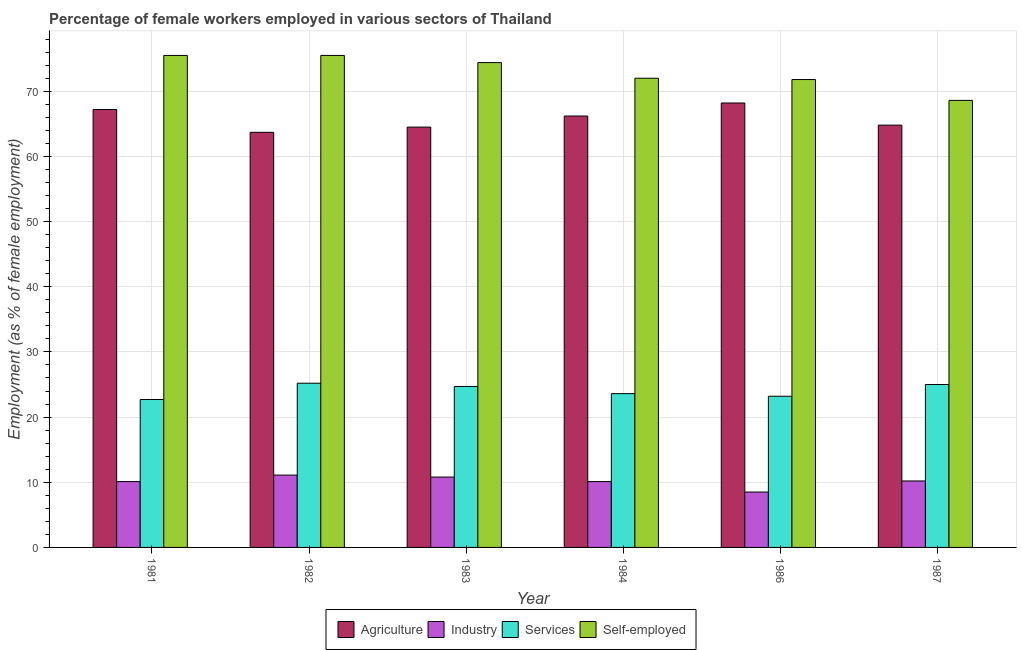How many different coloured bars are there?
Make the answer very short. 4. Are the number of bars on each tick of the X-axis equal?
Make the answer very short. Yes. How many bars are there on the 3rd tick from the right?
Offer a very short reply. 4. What is the percentage of female workers in industry in 1982?
Provide a succinct answer. 11.1. Across all years, what is the maximum percentage of female workers in industry?
Provide a succinct answer. 11.1. Across all years, what is the minimum percentage of female workers in agriculture?
Provide a succinct answer. 63.7. In which year was the percentage of self employed female workers maximum?
Give a very brief answer. 1981. In which year was the percentage of self employed female workers minimum?
Keep it short and to the point. 1987. What is the total percentage of female workers in industry in the graph?
Offer a very short reply. 60.8. What is the difference between the percentage of self employed female workers in 1982 and the percentage of female workers in industry in 1984?
Make the answer very short. 3.5. What is the average percentage of female workers in industry per year?
Offer a terse response. 10.13. What is the ratio of the percentage of self employed female workers in 1986 to that in 1987?
Offer a terse response. 1.05. Is the percentage of self employed female workers in 1983 less than that in 1984?
Provide a succinct answer. No. Is the difference between the percentage of female workers in industry in 1983 and 1986 greater than the difference between the percentage of female workers in services in 1983 and 1986?
Keep it short and to the point. No. What is the difference between the highest and the lowest percentage of female workers in services?
Keep it short and to the point. 2.5. In how many years, is the percentage of self employed female workers greater than the average percentage of self employed female workers taken over all years?
Provide a short and direct response. 3. Is the sum of the percentage of female workers in industry in 1981 and 1982 greater than the maximum percentage of self employed female workers across all years?
Make the answer very short. Yes. Is it the case that in every year, the sum of the percentage of female workers in agriculture and percentage of female workers in services is greater than the sum of percentage of self employed female workers and percentage of female workers in industry?
Your answer should be very brief. Yes. What does the 4th bar from the left in 1986 represents?
Offer a very short reply. Self-employed. What does the 1st bar from the right in 1984 represents?
Your answer should be compact. Self-employed. Is it the case that in every year, the sum of the percentage of female workers in agriculture and percentage of female workers in industry is greater than the percentage of female workers in services?
Provide a succinct answer. Yes. Are all the bars in the graph horizontal?
Your answer should be compact. No. How many years are there in the graph?
Your answer should be very brief. 6. How are the legend labels stacked?
Your answer should be compact. Horizontal. What is the title of the graph?
Provide a short and direct response. Percentage of female workers employed in various sectors of Thailand. What is the label or title of the X-axis?
Your response must be concise. Year. What is the label or title of the Y-axis?
Offer a terse response. Employment (as % of female employment). What is the Employment (as % of female employment) in Agriculture in 1981?
Make the answer very short. 67.2. What is the Employment (as % of female employment) in Industry in 1981?
Keep it short and to the point. 10.1. What is the Employment (as % of female employment) of Services in 1981?
Keep it short and to the point. 22.7. What is the Employment (as % of female employment) of Self-employed in 1981?
Your response must be concise. 75.5. What is the Employment (as % of female employment) of Agriculture in 1982?
Give a very brief answer. 63.7. What is the Employment (as % of female employment) of Industry in 1982?
Ensure brevity in your answer.  11.1. What is the Employment (as % of female employment) of Services in 1982?
Offer a terse response. 25.2. What is the Employment (as % of female employment) of Self-employed in 1982?
Your answer should be very brief. 75.5. What is the Employment (as % of female employment) in Agriculture in 1983?
Give a very brief answer. 64.5. What is the Employment (as % of female employment) of Industry in 1983?
Provide a short and direct response. 10.8. What is the Employment (as % of female employment) of Services in 1983?
Provide a short and direct response. 24.7. What is the Employment (as % of female employment) in Self-employed in 1983?
Your response must be concise. 74.4. What is the Employment (as % of female employment) of Agriculture in 1984?
Provide a succinct answer. 66.2. What is the Employment (as % of female employment) in Industry in 1984?
Your answer should be compact. 10.1. What is the Employment (as % of female employment) of Services in 1984?
Your answer should be compact. 23.6. What is the Employment (as % of female employment) of Self-employed in 1984?
Offer a terse response. 72. What is the Employment (as % of female employment) in Agriculture in 1986?
Provide a succinct answer. 68.2. What is the Employment (as % of female employment) of Services in 1986?
Your answer should be very brief. 23.2. What is the Employment (as % of female employment) in Self-employed in 1986?
Provide a short and direct response. 71.8. What is the Employment (as % of female employment) in Agriculture in 1987?
Ensure brevity in your answer.  64.8. What is the Employment (as % of female employment) of Industry in 1987?
Ensure brevity in your answer.  10.2. What is the Employment (as % of female employment) in Services in 1987?
Your answer should be compact. 25. What is the Employment (as % of female employment) of Self-employed in 1987?
Your response must be concise. 68.6. Across all years, what is the maximum Employment (as % of female employment) of Agriculture?
Keep it short and to the point. 68.2. Across all years, what is the maximum Employment (as % of female employment) of Industry?
Provide a succinct answer. 11.1. Across all years, what is the maximum Employment (as % of female employment) of Services?
Give a very brief answer. 25.2. Across all years, what is the maximum Employment (as % of female employment) of Self-employed?
Offer a terse response. 75.5. Across all years, what is the minimum Employment (as % of female employment) of Agriculture?
Provide a short and direct response. 63.7. Across all years, what is the minimum Employment (as % of female employment) in Industry?
Provide a succinct answer. 8.5. Across all years, what is the minimum Employment (as % of female employment) of Services?
Ensure brevity in your answer.  22.7. Across all years, what is the minimum Employment (as % of female employment) of Self-employed?
Provide a succinct answer. 68.6. What is the total Employment (as % of female employment) of Agriculture in the graph?
Make the answer very short. 394.6. What is the total Employment (as % of female employment) in Industry in the graph?
Keep it short and to the point. 60.8. What is the total Employment (as % of female employment) in Services in the graph?
Your response must be concise. 144.4. What is the total Employment (as % of female employment) in Self-employed in the graph?
Offer a terse response. 437.8. What is the difference between the Employment (as % of female employment) in Agriculture in 1981 and that in 1982?
Your answer should be compact. 3.5. What is the difference between the Employment (as % of female employment) in Industry in 1981 and that in 1982?
Offer a terse response. -1. What is the difference between the Employment (as % of female employment) of Agriculture in 1981 and that in 1983?
Make the answer very short. 2.7. What is the difference between the Employment (as % of female employment) in Services in 1981 and that in 1984?
Provide a succinct answer. -0.9. What is the difference between the Employment (as % of female employment) in Self-employed in 1981 and that in 1984?
Your answer should be compact. 3.5. What is the difference between the Employment (as % of female employment) in Agriculture in 1981 and that in 1986?
Offer a terse response. -1. What is the difference between the Employment (as % of female employment) of Industry in 1981 and that in 1986?
Offer a terse response. 1.6. What is the difference between the Employment (as % of female employment) of Agriculture in 1981 and that in 1987?
Your answer should be very brief. 2.4. What is the difference between the Employment (as % of female employment) of Services in 1981 and that in 1987?
Give a very brief answer. -2.3. What is the difference between the Employment (as % of female employment) of Industry in 1982 and that in 1983?
Give a very brief answer. 0.3. What is the difference between the Employment (as % of female employment) of Industry in 1982 and that in 1984?
Ensure brevity in your answer.  1. What is the difference between the Employment (as % of female employment) in Services in 1982 and that in 1984?
Provide a succinct answer. 1.6. What is the difference between the Employment (as % of female employment) of Self-employed in 1982 and that in 1984?
Provide a short and direct response. 3.5. What is the difference between the Employment (as % of female employment) in Agriculture in 1982 and that in 1986?
Ensure brevity in your answer.  -4.5. What is the difference between the Employment (as % of female employment) of Industry in 1982 and that in 1986?
Your response must be concise. 2.6. What is the difference between the Employment (as % of female employment) of Services in 1982 and that in 1986?
Your answer should be very brief. 2. What is the difference between the Employment (as % of female employment) of Self-employed in 1982 and that in 1986?
Ensure brevity in your answer.  3.7. What is the difference between the Employment (as % of female employment) in Self-employed in 1982 and that in 1987?
Keep it short and to the point. 6.9. What is the difference between the Employment (as % of female employment) of Agriculture in 1983 and that in 1984?
Your answer should be very brief. -1.7. What is the difference between the Employment (as % of female employment) in Services in 1983 and that in 1984?
Keep it short and to the point. 1.1. What is the difference between the Employment (as % of female employment) of Self-employed in 1983 and that in 1984?
Ensure brevity in your answer.  2.4. What is the difference between the Employment (as % of female employment) in Agriculture in 1983 and that in 1986?
Your answer should be very brief. -3.7. What is the difference between the Employment (as % of female employment) in Services in 1983 and that in 1986?
Provide a short and direct response. 1.5. What is the difference between the Employment (as % of female employment) of Industry in 1983 and that in 1987?
Your answer should be very brief. 0.6. What is the difference between the Employment (as % of female employment) of Self-employed in 1983 and that in 1987?
Keep it short and to the point. 5.8. What is the difference between the Employment (as % of female employment) in Industry in 1984 and that in 1986?
Keep it short and to the point. 1.6. What is the difference between the Employment (as % of female employment) of Agriculture in 1986 and that in 1987?
Ensure brevity in your answer.  3.4. What is the difference between the Employment (as % of female employment) of Industry in 1986 and that in 1987?
Ensure brevity in your answer.  -1.7. What is the difference between the Employment (as % of female employment) of Services in 1986 and that in 1987?
Offer a terse response. -1.8. What is the difference between the Employment (as % of female employment) of Agriculture in 1981 and the Employment (as % of female employment) of Industry in 1982?
Offer a very short reply. 56.1. What is the difference between the Employment (as % of female employment) in Industry in 1981 and the Employment (as % of female employment) in Services in 1982?
Your answer should be compact. -15.1. What is the difference between the Employment (as % of female employment) of Industry in 1981 and the Employment (as % of female employment) of Self-employed in 1982?
Offer a terse response. -65.4. What is the difference between the Employment (as % of female employment) of Services in 1981 and the Employment (as % of female employment) of Self-employed in 1982?
Provide a succinct answer. -52.8. What is the difference between the Employment (as % of female employment) in Agriculture in 1981 and the Employment (as % of female employment) in Industry in 1983?
Make the answer very short. 56.4. What is the difference between the Employment (as % of female employment) of Agriculture in 1981 and the Employment (as % of female employment) of Services in 1983?
Offer a terse response. 42.5. What is the difference between the Employment (as % of female employment) in Agriculture in 1981 and the Employment (as % of female employment) in Self-employed in 1983?
Your answer should be compact. -7.2. What is the difference between the Employment (as % of female employment) of Industry in 1981 and the Employment (as % of female employment) of Services in 1983?
Your answer should be very brief. -14.6. What is the difference between the Employment (as % of female employment) in Industry in 1981 and the Employment (as % of female employment) in Self-employed in 1983?
Keep it short and to the point. -64.3. What is the difference between the Employment (as % of female employment) in Services in 1981 and the Employment (as % of female employment) in Self-employed in 1983?
Give a very brief answer. -51.7. What is the difference between the Employment (as % of female employment) in Agriculture in 1981 and the Employment (as % of female employment) in Industry in 1984?
Your answer should be compact. 57.1. What is the difference between the Employment (as % of female employment) of Agriculture in 1981 and the Employment (as % of female employment) of Services in 1984?
Offer a terse response. 43.6. What is the difference between the Employment (as % of female employment) in Industry in 1981 and the Employment (as % of female employment) in Services in 1984?
Provide a short and direct response. -13.5. What is the difference between the Employment (as % of female employment) in Industry in 1981 and the Employment (as % of female employment) in Self-employed in 1984?
Keep it short and to the point. -61.9. What is the difference between the Employment (as % of female employment) in Services in 1981 and the Employment (as % of female employment) in Self-employed in 1984?
Give a very brief answer. -49.3. What is the difference between the Employment (as % of female employment) of Agriculture in 1981 and the Employment (as % of female employment) of Industry in 1986?
Make the answer very short. 58.7. What is the difference between the Employment (as % of female employment) in Agriculture in 1981 and the Employment (as % of female employment) in Services in 1986?
Provide a succinct answer. 44. What is the difference between the Employment (as % of female employment) of Agriculture in 1981 and the Employment (as % of female employment) of Self-employed in 1986?
Give a very brief answer. -4.6. What is the difference between the Employment (as % of female employment) of Industry in 1981 and the Employment (as % of female employment) of Self-employed in 1986?
Your answer should be compact. -61.7. What is the difference between the Employment (as % of female employment) in Services in 1981 and the Employment (as % of female employment) in Self-employed in 1986?
Provide a succinct answer. -49.1. What is the difference between the Employment (as % of female employment) in Agriculture in 1981 and the Employment (as % of female employment) in Services in 1987?
Your answer should be very brief. 42.2. What is the difference between the Employment (as % of female employment) in Agriculture in 1981 and the Employment (as % of female employment) in Self-employed in 1987?
Keep it short and to the point. -1.4. What is the difference between the Employment (as % of female employment) of Industry in 1981 and the Employment (as % of female employment) of Services in 1987?
Your answer should be very brief. -14.9. What is the difference between the Employment (as % of female employment) of Industry in 1981 and the Employment (as % of female employment) of Self-employed in 1987?
Offer a terse response. -58.5. What is the difference between the Employment (as % of female employment) of Services in 1981 and the Employment (as % of female employment) of Self-employed in 1987?
Your answer should be compact. -45.9. What is the difference between the Employment (as % of female employment) in Agriculture in 1982 and the Employment (as % of female employment) in Industry in 1983?
Your answer should be very brief. 52.9. What is the difference between the Employment (as % of female employment) of Agriculture in 1982 and the Employment (as % of female employment) of Self-employed in 1983?
Provide a succinct answer. -10.7. What is the difference between the Employment (as % of female employment) of Industry in 1982 and the Employment (as % of female employment) of Services in 1983?
Keep it short and to the point. -13.6. What is the difference between the Employment (as % of female employment) of Industry in 1982 and the Employment (as % of female employment) of Self-employed in 1983?
Offer a terse response. -63.3. What is the difference between the Employment (as % of female employment) in Services in 1982 and the Employment (as % of female employment) in Self-employed in 1983?
Give a very brief answer. -49.2. What is the difference between the Employment (as % of female employment) in Agriculture in 1982 and the Employment (as % of female employment) in Industry in 1984?
Your answer should be compact. 53.6. What is the difference between the Employment (as % of female employment) in Agriculture in 1982 and the Employment (as % of female employment) in Services in 1984?
Offer a terse response. 40.1. What is the difference between the Employment (as % of female employment) in Agriculture in 1982 and the Employment (as % of female employment) in Self-employed in 1984?
Your response must be concise. -8.3. What is the difference between the Employment (as % of female employment) of Industry in 1982 and the Employment (as % of female employment) of Self-employed in 1984?
Make the answer very short. -60.9. What is the difference between the Employment (as % of female employment) of Services in 1982 and the Employment (as % of female employment) of Self-employed in 1984?
Provide a succinct answer. -46.8. What is the difference between the Employment (as % of female employment) of Agriculture in 1982 and the Employment (as % of female employment) of Industry in 1986?
Your answer should be very brief. 55.2. What is the difference between the Employment (as % of female employment) in Agriculture in 1982 and the Employment (as % of female employment) in Services in 1986?
Make the answer very short. 40.5. What is the difference between the Employment (as % of female employment) of Agriculture in 1982 and the Employment (as % of female employment) of Self-employed in 1986?
Your answer should be compact. -8.1. What is the difference between the Employment (as % of female employment) in Industry in 1982 and the Employment (as % of female employment) in Self-employed in 1986?
Offer a terse response. -60.7. What is the difference between the Employment (as % of female employment) in Services in 1982 and the Employment (as % of female employment) in Self-employed in 1986?
Provide a short and direct response. -46.6. What is the difference between the Employment (as % of female employment) in Agriculture in 1982 and the Employment (as % of female employment) in Industry in 1987?
Offer a very short reply. 53.5. What is the difference between the Employment (as % of female employment) in Agriculture in 1982 and the Employment (as % of female employment) in Services in 1987?
Give a very brief answer. 38.7. What is the difference between the Employment (as % of female employment) in Industry in 1982 and the Employment (as % of female employment) in Services in 1987?
Your answer should be very brief. -13.9. What is the difference between the Employment (as % of female employment) of Industry in 1982 and the Employment (as % of female employment) of Self-employed in 1987?
Keep it short and to the point. -57.5. What is the difference between the Employment (as % of female employment) in Services in 1982 and the Employment (as % of female employment) in Self-employed in 1987?
Your answer should be very brief. -43.4. What is the difference between the Employment (as % of female employment) in Agriculture in 1983 and the Employment (as % of female employment) in Industry in 1984?
Keep it short and to the point. 54.4. What is the difference between the Employment (as % of female employment) in Agriculture in 1983 and the Employment (as % of female employment) in Services in 1984?
Your answer should be compact. 40.9. What is the difference between the Employment (as % of female employment) of Industry in 1983 and the Employment (as % of female employment) of Self-employed in 1984?
Keep it short and to the point. -61.2. What is the difference between the Employment (as % of female employment) in Services in 1983 and the Employment (as % of female employment) in Self-employed in 1984?
Make the answer very short. -47.3. What is the difference between the Employment (as % of female employment) in Agriculture in 1983 and the Employment (as % of female employment) in Services in 1986?
Offer a very short reply. 41.3. What is the difference between the Employment (as % of female employment) in Agriculture in 1983 and the Employment (as % of female employment) in Self-employed in 1986?
Keep it short and to the point. -7.3. What is the difference between the Employment (as % of female employment) in Industry in 1983 and the Employment (as % of female employment) in Self-employed in 1986?
Make the answer very short. -61. What is the difference between the Employment (as % of female employment) of Services in 1983 and the Employment (as % of female employment) of Self-employed in 1986?
Offer a terse response. -47.1. What is the difference between the Employment (as % of female employment) of Agriculture in 1983 and the Employment (as % of female employment) of Industry in 1987?
Keep it short and to the point. 54.3. What is the difference between the Employment (as % of female employment) of Agriculture in 1983 and the Employment (as % of female employment) of Services in 1987?
Ensure brevity in your answer.  39.5. What is the difference between the Employment (as % of female employment) in Industry in 1983 and the Employment (as % of female employment) in Self-employed in 1987?
Your answer should be compact. -57.8. What is the difference between the Employment (as % of female employment) of Services in 1983 and the Employment (as % of female employment) of Self-employed in 1987?
Your answer should be compact. -43.9. What is the difference between the Employment (as % of female employment) of Agriculture in 1984 and the Employment (as % of female employment) of Industry in 1986?
Provide a short and direct response. 57.7. What is the difference between the Employment (as % of female employment) of Industry in 1984 and the Employment (as % of female employment) of Services in 1986?
Your answer should be compact. -13.1. What is the difference between the Employment (as % of female employment) of Industry in 1984 and the Employment (as % of female employment) of Self-employed in 1986?
Provide a succinct answer. -61.7. What is the difference between the Employment (as % of female employment) of Services in 1984 and the Employment (as % of female employment) of Self-employed in 1986?
Your answer should be compact. -48.2. What is the difference between the Employment (as % of female employment) of Agriculture in 1984 and the Employment (as % of female employment) of Services in 1987?
Your response must be concise. 41.2. What is the difference between the Employment (as % of female employment) in Agriculture in 1984 and the Employment (as % of female employment) in Self-employed in 1987?
Keep it short and to the point. -2.4. What is the difference between the Employment (as % of female employment) in Industry in 1984 and the Employment (as % of female employment) in Services in 1987?
Your answer should be very brief. -14.9. What is the difference between the Employment (as % of female employment) in Industry in 1984 and the Employment (as % of female employment) in Self-employed in 1987?
Your response must be concise. -58.5. What is the difference between the Employment (as % of female employment) of Services in 1984 and the Employment (as % of female employment) of Self-employed in 1987?
Your answer should be very brief. -45. What is the difference between the Employment (as % of female employment) in Agriculture in 1986 and the Employment (as % of female employment) in Industry in 1987?
Your answer should be compact. 58. What is the difference between the Employment (as % of female employment) of Agriculture in 1986 and the Employment (as % of female employment) of Services in 1987?
Offer a very short reply. 43.2. What is the difference between the Employment (as % of female employment) in Agriculture in 1986 and the Employment (as % of female employment) in Self-employed in 1987?
Your answer should be compact. -0.4. What is the difference between the Employment (as % of female employment) in Industry in 1986 and the Employment (as % of female employment) in Services in 1987?
Make the answer very short. -16.5. What is the difference between the Employment (as % of female employment) in Industry in 1986 and the Employment (as % of female employment) in Self-employed in 1987?
Offer a very short reply. -60.1. What is the difference between the Employment (as % of female employment) in Services in 1986 and the Employment (as % of female employment) in Self-employed in 1987?
Give a very brief answer. -45.4. What is the average Employment (as % of female employment) of Agriculture per year?
Your answer should be very brief. 65.77. What is the average Employment (as % of female employment) in Industry per year?
Offer a very short reply. 10.13. What is the average Employment (as % of female employment) in Services per year?
Offer a terse response. 24.07. What is the average Employment (as % of female employment) of Self-employed per year?
Your answer should be compact. 72.97. In the year 1981, what is the difference between the Employment (as % of female employment) in Agriculture and Employment (as % of female employment) in Industry?
Offer a very short reply. 57.1. In the year 1981, what is the difference between the Employment (as % of female employment) in Agriculture and Employment (as % of female employment) in Services?
Offer a very short reply. 44.5. In the year 1981, what is the difference between the Employment (as % of female employment) in Agriculture and Employment (as % of female employment) in Self-employed?
Provide a succinct answer. -8.3. In the year 1981, what is the difference between the Employment (as % of female employment) in Industry and Employment (as % of female employment) in Services?
Your response must be concise. -12.6. In the year 1981, what is the difference between the Employment (as % of female employment) of Industry and Employment (as % of female employment) of Self-employed?
Your answer should be compact. -65.4. In the year 1981, what is the difference between the Employment (as % of female employment) of Services and Employment (as % of female employment) of Self-employed?
Your answer should be compact. -52.8. In the year 1982, what is the difference between the Employment (as % of female employment) in Agriculture and Employment (as % of female employment) in Industry?
Provide a succinct answer. 52.6. In the year 1982, what is the difference between the Employment (as % of female employment) in Agriculture and Employment (as % of female employment) in Services?
Your answer should be compact. 38.5. In the year 1982, what is the difference between the Employment (as % of female employment) in Industry and Employment (as % of female employment) in Services?
Your answer should be compact. -14.1. In the year 1982, what is the difference between the Employment (as % of female employment) in Industry and Employment (as % of female employment) in Self-employed?
Your answer should be very brief. -64.4. In the year 1982, what is the difference between the Employment (as % of female employment) in Services and Employment (as % of female employment) in Self-employed?
Your response must be concise. -50.3. In the year 1983, what is the difference between the Employment (as % of female employment) in Agriculture and Employment (as % of female employment) in Industry?
Provide a succinct answer. 53.7. In the year 1983, what is the difference between the Employment (as % of female employment) in Agriculture and Employment (as % of female employment) in Services?
Your answer should be compact. 39.8. In the year 1983, what is the difference between the Employment (as % of female employment) in Agriculture and Employment (as % of female employment) in Self-employed?
Offer a terse response. -9.9. In the year 1983, what is the difference between the Employment (as % of female employment) in Industry and Employment (as % of female employment) in Self-employed?
Give a very brief answer. -63.6. In the year 1983, what is the difference between the Employment (as % of female employment) in Services and Employment (as % of female employment) in Self-employed?
Your answer should be very brief. -49.7. In the year 1984, what is the difference between the Employment (as % of female employment) in Agriculture and Employment (as % of female employment) in Industry?
Make the answer very short. 56.1. In the year 1984, what is the difference between the Employment (as % of female employment) in Agriculture and Employment (as % of female employment) in Services?
Make the answer very short. 42.6. In the year 1984, what is the difference between the Employment (as % of female employment) in Industry and Employment (as % of female employment) in Services?
Give a very brief answer. -13.5. In the year 1984, what is the difference between the Employment (as % of female employment) in Industry and Employment (as % of female employment) in Self-employed?
Provide a succinct answer. -61.9. In the year 1984, what is the difference between the Employment (as % of female employment) in Services and Employment (as % of female employment) in Self-employed?
Provide a short and direct response. -48.4. In the year 1986, what is the difference between the Employment (as % of female employment) of Agriculture and Employment (as % of female employment) of Industry?
Your answer should be compact. 59.7. In the year 1986, what is the difference between the Employment (as % of female employment) in Agriculture and Employment (as % of female employment) in Services?
Offer a terse response. 45. In the year 1986, what is the difference between the Employment (as % of female employment) of Industry and Employment (as % of female employment) of Services?
Make the answer very short. -14.7. In the year 1986, what is the difference between the Employment (as % of female employment) of Industry and Employment (as % of female employment) of Self-employed?
Keep it short and to the point. -63.3. In the year 1986, what is the difference between the Employment (as % of female employment) of Services and Employment (as % of female employment) of Self-employed?
Make the answer very short. -48.6. In the year 1987, what is the difference between the Employment (as % of female employment) of Agriculture and Employment (as % of female employment) of Industry?
Provide a succinct answer. 54.6. In the year 1987, what is the difference between the Employment (as % of female employment) of Agriculture and Employment (as % of female employment) of Services?
Your answer should be very brief. 39.8. In the year 1987, what is the difference between the Employment (as % of female employment) in Industry and Employment (as % of female employment) in Services?
Give a very brief answer. -14.8. In the year 1987, what is the difference between the Employment (as % of female employment) in Industry and Employment (as % of female employment) in Self-employed?
Your response must be concise. -58.4. In the year 1987, what is the difference between the Employment (as % of female employment) of Services and Employment (as % of female employment) of Self-employed?
Your response must be concise. -43.6. What is the ratio of the Employment (as % of female employment) in Agriculture in 1981 to that in 1982?
Provide a short and direct response. 1.05. What is the ratio of the Employment (as % of female employment) in Industry in 1981 to that in 1982?
Keep it short and to the point. 0.91. What is the ratio of the Employment (as % of female employment) of Services in 1981 to that in 1982?
Your response must be concise. 0.9. What is the ratio of the Employment (as % of female employment) in Agriculture in 1981 to that in 1983?
Make the answer very short. 1.04. What is the ratio of the Employment (as % of female employment) in Industry in 1981 to that in 1983?
Provide a succinct answer. 0.94. What is the ratio of the Employment (as % of female employment) in Services in 1981 to that in 1983?
Make the answer very short. 0.92. What is the ratio of the Employment (as % of female employment) in Self-employed in 1981 to that in 1983?
Provide a succinct answer. 1.01. What is the ratio of the Employment (as % of female employment) of Agriculture in 1981 to that in 1984?
Provide a succinct answer. 1.02. What is the ratio of the Employment (as % of female employment) in Services in 1981 to that in 1984?
Your answer should be compact. 0.96. What is the ratio of the Employment (as % of female employment) in Self-employed in 1981 to that in 1984?
Ensure brevity in your answer.  1.05. What is the ratio of the Employment (as % of female employment) in Agriculture in 1981 to that in 1986?
Provide a short and direct response. 0.99. What is the ratio of the Employment (as % of female employment) of Industry in 1981 to that in 1986?
Offer a very short reply. 1.19. What is the ratio of the Employment (as % of female employment) of Services in 1981 to that in 1986?
Your answer should be very brief. 0.98. What is the ratio of the Employment (as % of female employment) of Self-employed in 1981 to that in 1986?
Make the answer very short. 1.05. What is the ratio of the Employment (as % of female employment) of Agriculture in 1981 to that in 1987?
Provide a succinct answer. 1.04. What is the ratio of the Employment (as % of female employment) in Industry in 1981 to that in 1987?
Give a very brief answer. 0.99. What is the ratio of the Employment (as % of female employment) of Services in 1981 to that in 1987?
Keep it short and to the point. 0.91. What is the ratio of the Employment (as % of female employment) in Self-employed in 1981 to that in 1987?
Give a very brief answer. 1.1. What is the ratio of the Employment (as % of female employment) in Agriculture in 1982 to that in 1983?
Keep it short and to the point. 0.99. What is the ratio of the Employment (as % of female employment) of Industry in 1982 to that in 1983?
Offer a very short reply. 1.03. What is the ratio of the Employment (as % of female employment) in Services in 1982 to that in 1983?
Make the answer very short. 1.02. What is the ratio of the Employment (as % of female employment) in Self-employed in 1982 to that in 1983?
Give a very brief answer. 1.01. What is the ratio of the Employment (as % of female employment) in Agriculture in 1982 to that in 1984?
Your answer should be very brief. 0.96. What is the ratio of the Employment (as % of female employment) in Industry in 1982 to that in 1984?
Your answer should be very brief. 1.1. What is the ratio of the Employment (as % of female employment) in Services in 1982 to that in 1984?
Your answer should be compact. 1.07. What is the ratio of the Employment (as % of female employment) of Self-employed in 1982 to that in 1984?
Keep it short and to the point. 1.05. What is the ratio of the Employment (as % of female employment) in Agriculture in 1982 to that in 1986?
Provide a succinct answer. 0.93. What is the ratio of the Employment (as % of female employment) in Industry in 1982 to that in 1986?
Your answer should be very brief. 1.31. What is the ratio of the Employment (as % of female employment) in Services in 1982 to that in 1986?
Offer a very short reply. 1.09. What is the ratio of the Employment (as % of female employment) of Self-employed in 1982 to that in 1986?
Ensure brevity in your answer.  1.05. What is the ratio of the Employment (as % of female employment) in Agriculture in 1982 to that in 1987?
Give a very brief answer. 0.98. What is the ratio of the Employment (as % of female employment) in Industry in 1982 to that in 1987?
Offer a very short reply. 1.09. What is the ratio of the Employment (as % of female employment) of Services in 1982 to that in 1987?
Keep it short and to the point. 1.01. What is the ratio of the Employment (as % of female employment) in Self-employed in 1982 to that in 1987?
Provide a short and direct response. 1.1. What is the ratio of the Employment (as % of female employment) in Agriculture in 1983 to that in 1984?
Provide a short and direct response. 0.97. What is the ratio of the Employment (as % of female employment) in Industry in 1983 to that in 1984?
Your answer should be compact. 1.07. What is the ratio of the Employment (as % of female employment) of Services in 1983 to that in 1984?
Make the answer very short. 1.05. What is the ratio of the Employment (as % of female employment) in Agriculture in 1983 to that in 1986?
Offer a very short reply. 0.95. What is the ratio of the Employment (as % of female employment) of Industry in 1983 to that in 1986?
Your answer should be very brief. 1.27. What is the ratio of the Employment (as % of female employment) in Services in 1983 to that in 1986?
Provide a short and direct response. 1.06. What is the ratio of the Employment (as % of female employment) of Self-employed in 1983 to that in 1986?
Make the answer very short. 1.04. What is the ratio of the Employment (as % of female employment) of Agriculture in 1983 to that in 1987?
Your answer should be compact. 1. What is the ratio of the Employment (as % of female employment) of Industry in 1983 to that in 1987?
Your answer should be compact. 1.06. What is the ratio of the Employment (as % of female employment) of Services in 1983 to that in 1987?
Offer a very short reply. 0.99. What is the ratio of the Employment (as % of female employment) in Self-employed in 1983 to that in 1987?
Your response must be concise. 1.08. What is the ratio of the Employment (as % of female employment) in Agriculture in 1984 to that in 1986?
Provide a succinct answer. 0.97. What is the ratio of the Employment (as % of female employment) in Industry in 1984 to that in 1986?
Provide a short and direct response. 1.19. What is the ratio of the Employment (as % of female employment) of Services in 1984 to that in 1986?
Give a very brief answer. 1.02. What is the ratio of the Employment (as % of female employment) in Agriculture in 1984 to that in 1987?
Give a very brief answer. 1.02. What is the ratio of the Employment (as % of female employment) of Industry in 1984 to that in 1987?
Your answer should be compact. 0.99. What is the ratio of the Employment (as % of female employment) of Services in 1984 to that in 1987?
Keep it short and to the point. 0.94. What is the ratio of the Employment (as % of female employment) in Self-employed in 1984 to that in 1987?
Give a very brief answer. 1.05. What is the ratio of the Employment (as % of female employment) of Agriculture in 1986 to that in 1987?
Your answer should be compact. 1.05. What is the ratio of the Employment (as % of female employment) of Services in 1986 to that in 1987?
Provide a succinct answer. 0.93. What is the ratio of the Employment (as % of female employment) in Self-employed in 1986 to that in 1987?
Offer a terse response. 1.05. What is the difference between the highest and the second highest Employment (as % of female employment) of Agriculture?
Provide a succinct answer. 1. What is the difference between the highest and the second highest Employment (as % of female employment) of Industry?
Your answer should be very brief. 0.3. What is the difference between the highest and the second highest Employment (as % of female employment) of Self-employed?
Provide a succinct answer. 0. What is the difference between the highest and the lowest Employment (as % of female employment) of Agriculture?
Offer a very short reply. 4.5. What is the difference between the highest and the lowest Employment (as % of female employment) of Industry?
Keep it short and to the point. 2.6. 